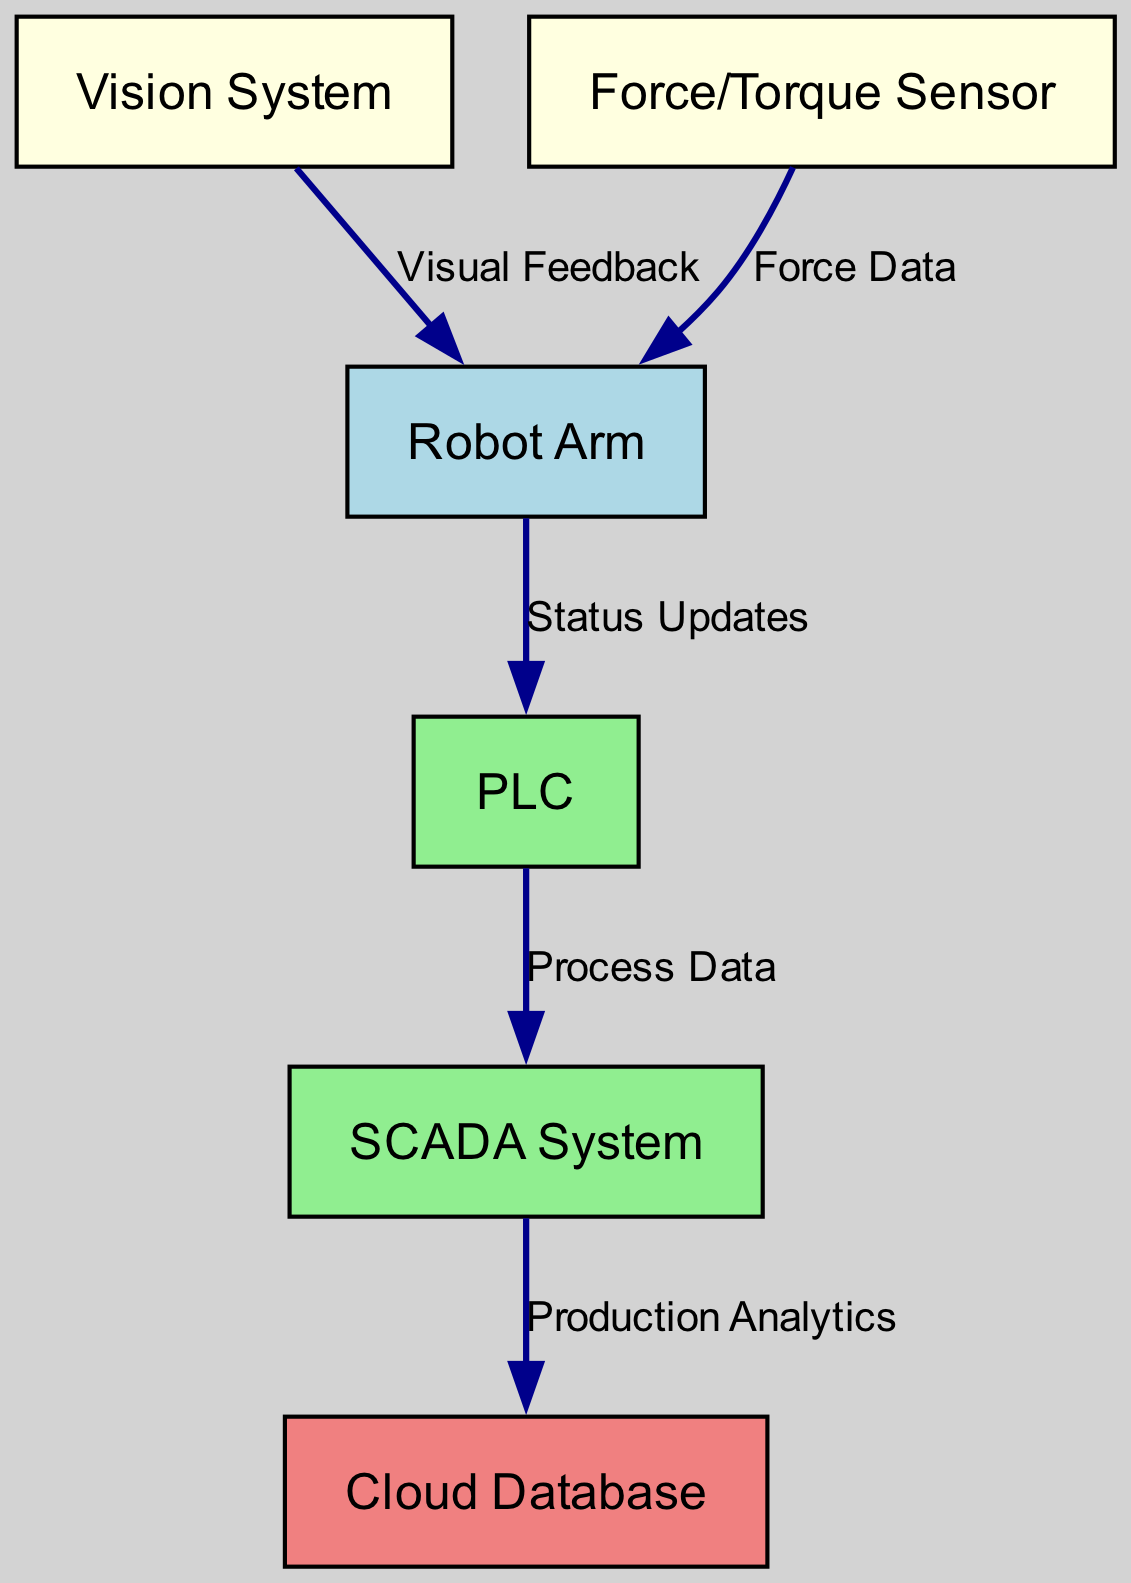What are the main components in the diagram? The main components are the Robot Arm, Vision System, Force/Torque Sensor, PLC, SCADA System, and Cloud Database. These are the nodes identified in the diagram that represent the different hardware or systems involved in the integration.
Answer: Robot Arm, Vision System, Force/Torque Sensor, PLC, SCADA System, Cloud Database How many nodes are in the diagram? Counting all the unique components shown in the diagram, we see there are six nodes: the Robot Arm, Vision System, Force/Torque Sensor, PLC, SCADA System, and Cloud Database.
Answer: 6 What type of feedback does the Vision System provide to the Robot Arm? According to the edge label, the Vision System provides "Visual Feedback" directly to the Robot Arm, indicating the data flow from the Vision System to the Robot Arm.
Answer: Visual Feedback Which component receives Force Data? The "Force/Torque Sensor" sends Force Data to the Robot Arm, as indicated by the directed edge connecting these two components in the diagram.
Answer: Robot Arm What is the data flow from the PLC to the SCADA System? The flow from the PLC to the SCADA System is labeled as "Process Data," indicating that the PLC sends this type of data to the SCADA System for further processing.
Answer: Process Data What two types of data are integrated into the Robot Arm? The types of data integrated into the Robot Arm are "Visual Feedback" from the Vision System and "Force Data" from the Force/Torque Sensor, showing that it utilizes information from both these sensors.
Answer: Visual Feedback, Force Data What is the final destination of the Production Analytics data? The final destination of the Production Analytics data is the Cloud Database, as indicated by the flow from the SCADA System to the Cloud Database in the diagram.
Answer: Cloud Database From which component does the Robot Arm provide Status Updates? The Robot Arm provides Status Updates to the PLC, which is indicated by the directed edge labeled "Status Updates" connecting these two components in the diagram.
Answer: PLC 